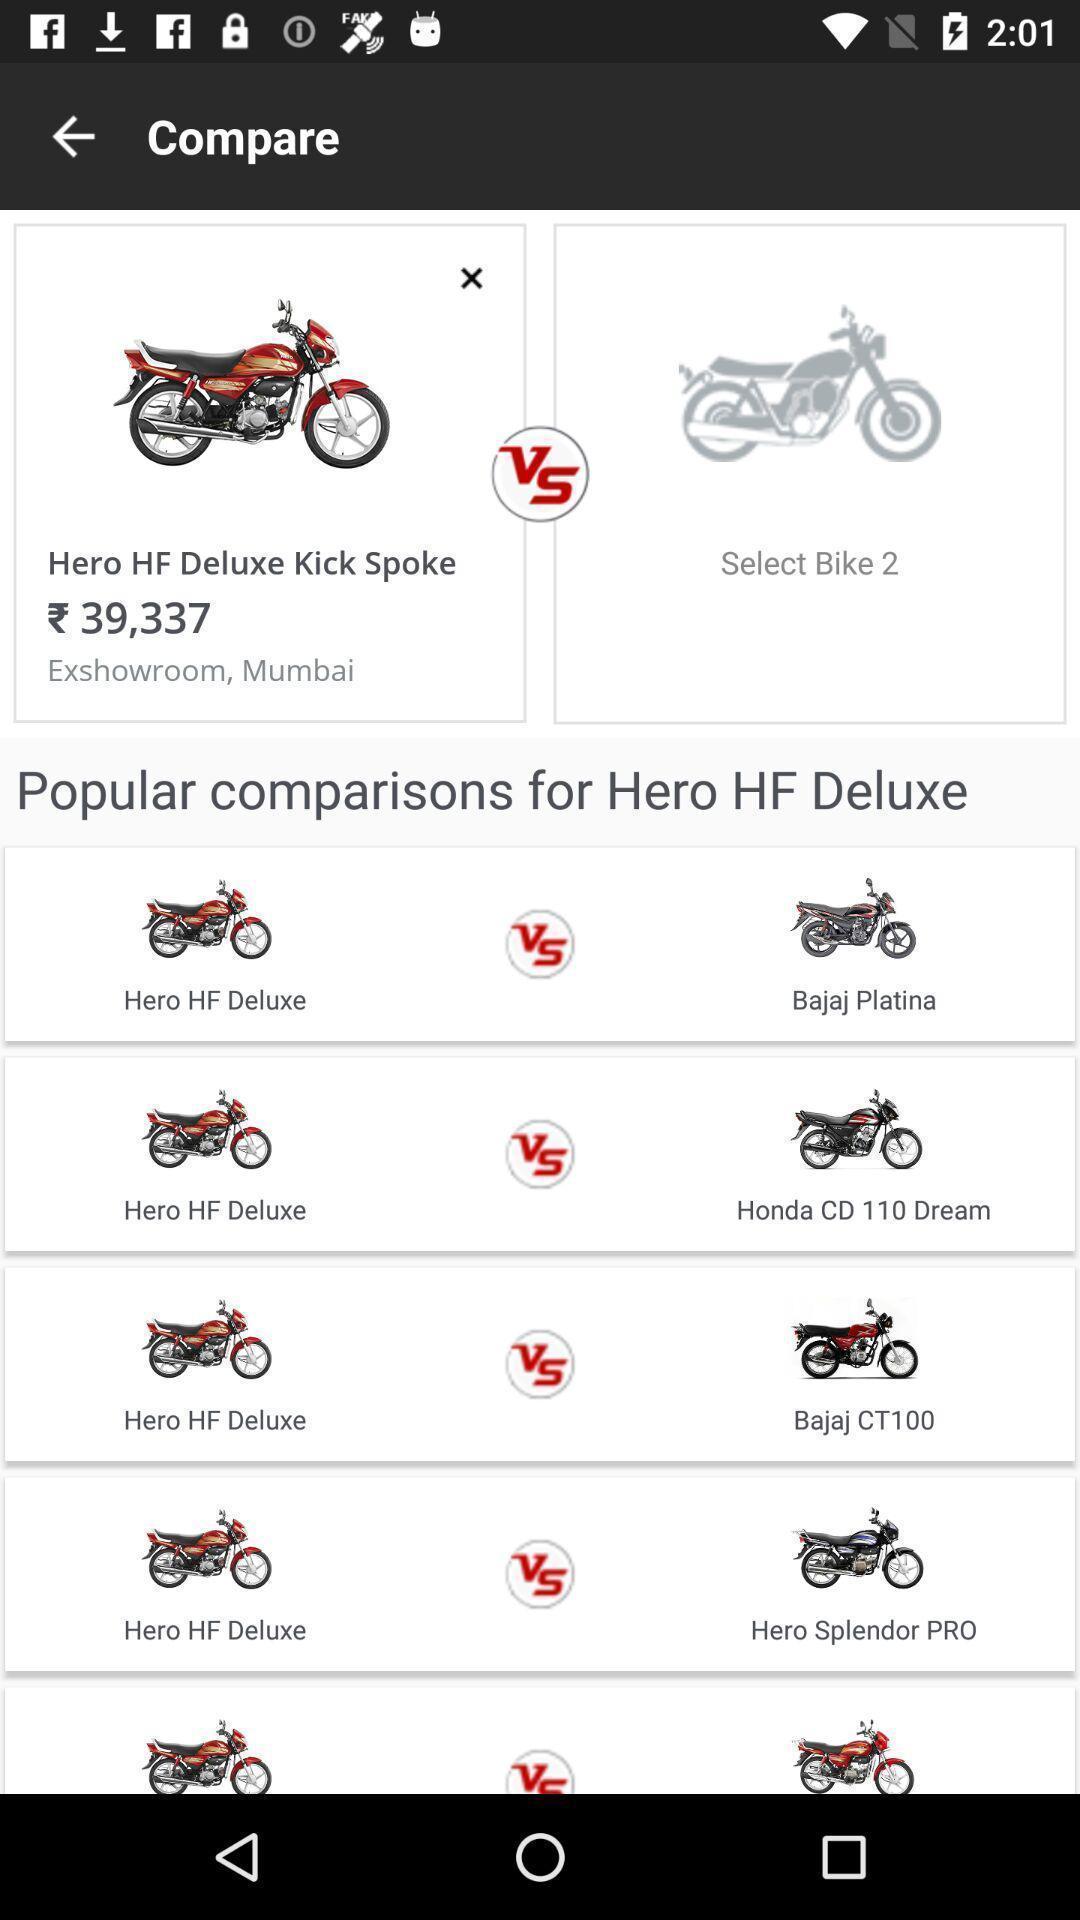Summarize the information in this screenshot. Screen showing popular comparisons. 